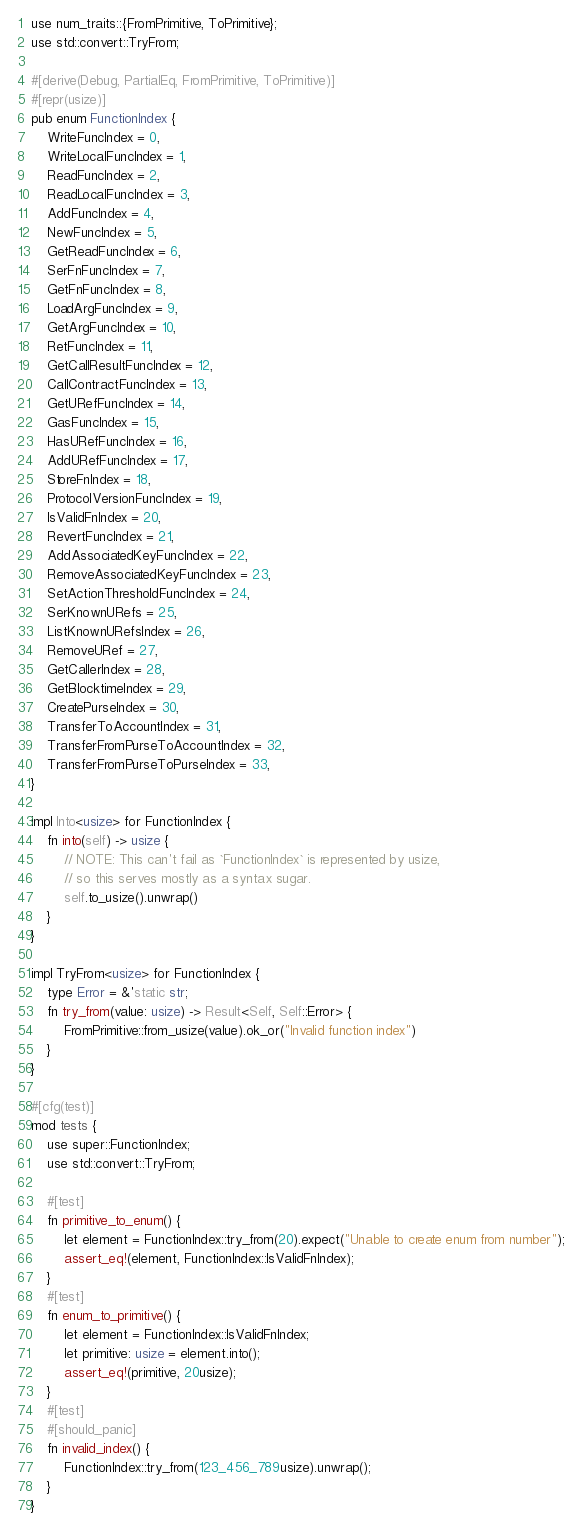<code> <loc_0><loc_0><loc_500><loc_500><_Rust_>use num_traits::{FromPrimitive, ToPrimitive};
use std::convert::TryFrom;

#[derive(Debug, PartialEq, FromPrimitive, ToPrimitive)]
#[repr(usize)]
pub enum FunctionIndex {
    WriteFuncIndex = 0,
    WriteLocalFuncIndex = 1,
    ReadFuncIndex = 2,
    ReadLocalFuncIndex = 3,
    AddFuncIndex = 4,
    NewFuncIndex = 5,
    GetReadFuncIndex = 6,
    SerFnFuncIndex = 7,
    GetFnFuncIndex = 8,
    LoadArgFuncIndex = 9,
    GetArgFuncIndex = 10,
    RetFuncIndex = 11,
    GetCallResultFuncIndex = 12,
    CallContractFuncIndex = 13,
    GetURefFuncIndex = 14,
    GasFuncIndex = 15,
    HasURefFuncIndex = 16,
    AddURefFuncIndex = 17,
    StoreFnIndex = 18,
    ProtocolVersionFuncIndex = 19,
    IsValidFnIndex = 20,
    RevertFuncIndex = 21,
    AddAssociatedKeyFuncIndex = 22,
    RemoveAssociatedKeyFuncIndex = 23,
    SetActionThresholdFuncIndex = 24,
    SerKnownURefs = 25,
    ListKnownURefsIndex = 26,
    RemoveURef = 27,
    GetCallerIndex = 28,
    GetBlocktimeIndex = 29,
    CreatePurseIndex = 30,
    TransferToAccountIndex = 31,
    TransferFromPurseToAccountIndex = 32,
    TransferFromPurseToPurseIndex = 33,
}

impl Into<usize> for FunctionIndex {
    fn into(self) -> usize {
        // NOTE: This can't fail as `FunctionIndex` is represented by usize,
        // so this serves mostly as a syntax sugar.
        self.to_usize().unwrap()
    }
}

impl TryFrom<usize> for FunctionIndex {
    type Error = &'static str;
    fn try_from(value: usize) -> Result<Self, Self::Error> {
        FromPrimitive::from_usize(value).ok_or("Invalid function index")
    }
}

#[cfg(test)]
mod tests {
    use super::FunctionIndex;
    use std::convert::TryFrom;

    #[test]
    fn primitive_to_enum() {
        let element = FunctionIndex::try_from(20).expect("Unable to create enum from number");
        assert_eq!(element, FunctionIndex::IsValidFnIndex);
    }
    #[test]
    fn enum_to_primitive() {
        let element = FunctionIndex::IsValidFnIndex;
        let primitive: usize = element.into();
        assert_eq!(primitive, 20usize);
    }
    #[test]
    #[should_panic]
    fn invalid_index() {
        FunctionIndex::try_from(123_456_789usize).unwrap();
    }
}
</code> 